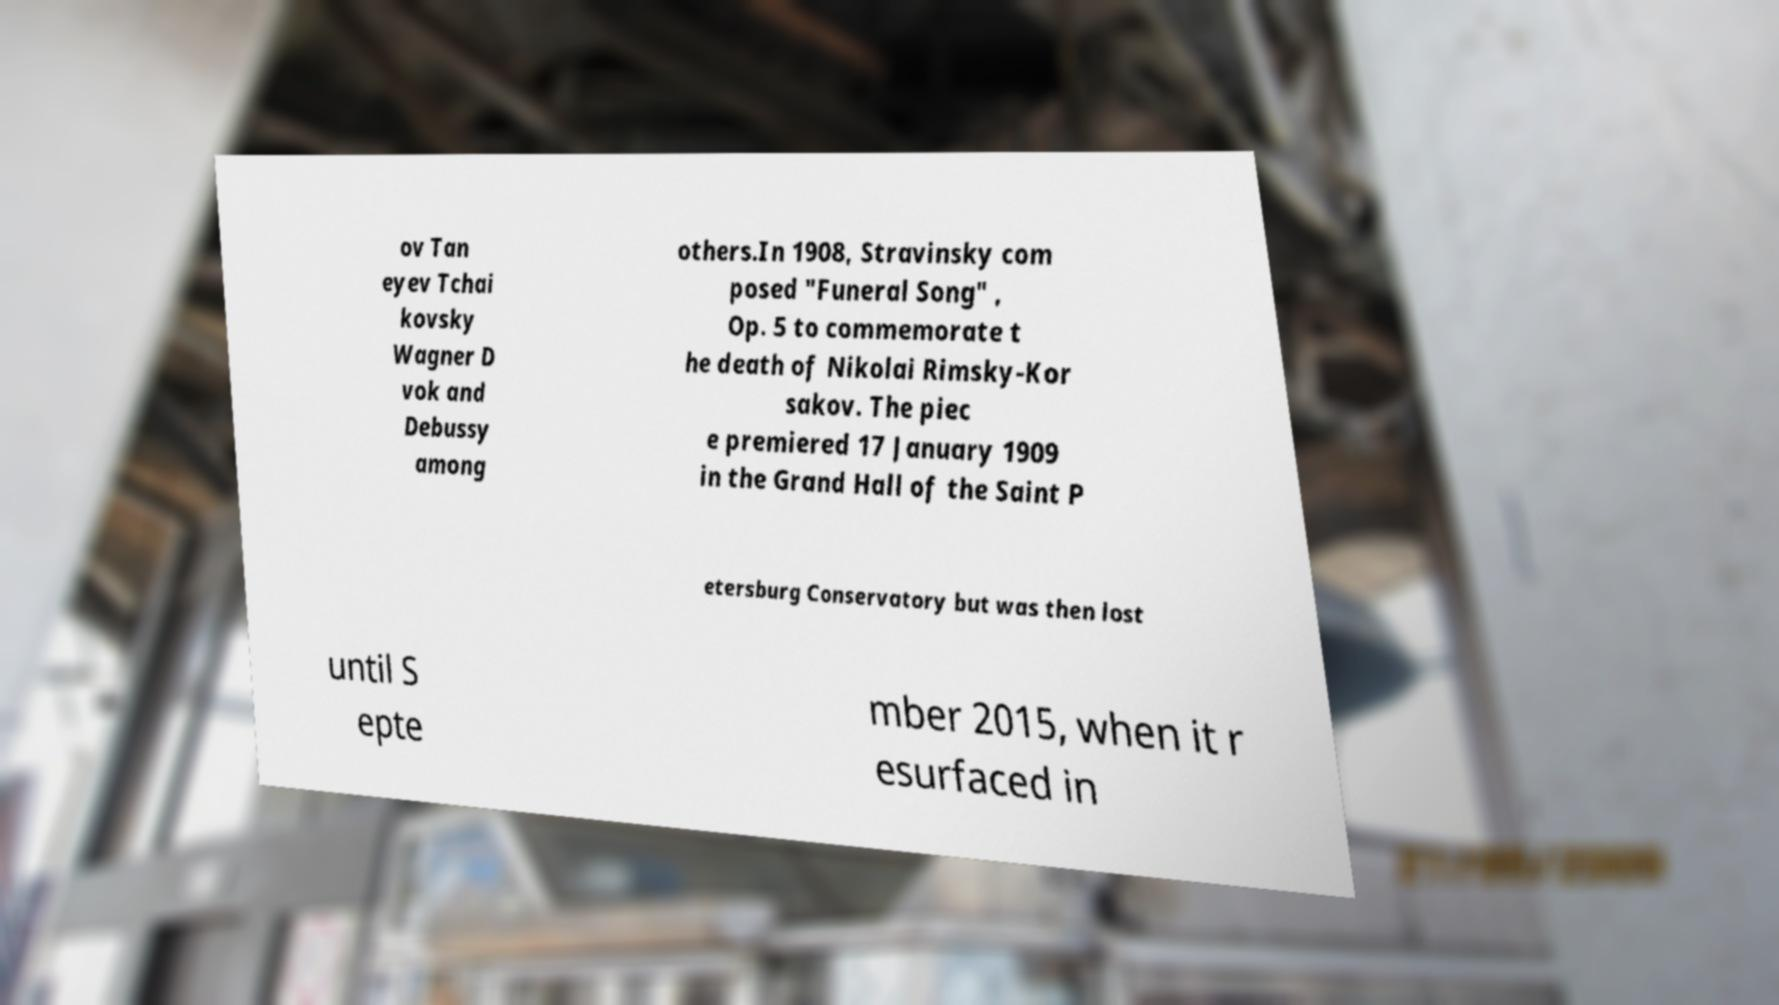Can you read and provide the text displayed in the image?This photo seems to have some interesting text. Can you extract and type it out for me? ov Tan eyev Tchai kovsky Wagner D vok and Debussy among others.In 1908, Stravinsky com posed "Funeral Song" , Op. 5 to commemorate t he death of Nikolai Rimsky-Kor sakov. The piec e premiered 17 January 1909 in the Grand Hall of the Saint P etersburg Conservatory but was then lost until S epte mber 2015, when it r esurfaced in 